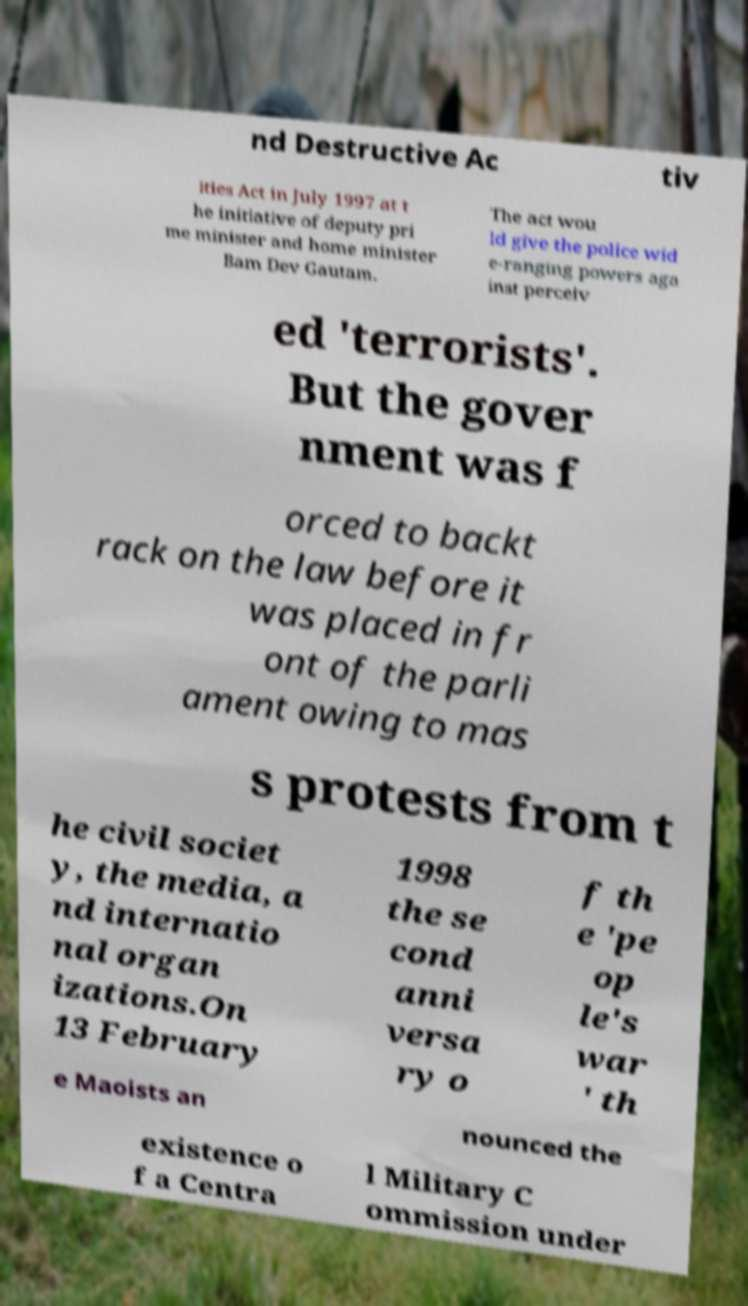Could you extract and type out the text from this image? nd Destructive Ac tiv ities Act in July 1997 at t he initiative of deputy pri me minister and home minister Bam Dev Gautam. The act wou ld give the police wid e-ranging powers aga inst perceiv ed 'terrorists'. But the gover nment was f orced to backt rack on the law before it was placed in fr ont of the parli ament owing to mas s protests from t he civil societ y, the media, a nd internatio nal organ izations.On 13 February 1998 the se cond anni versa ry o f th e 'pe op le's war ' th e Maoists an nounced the existence o f a Centra l Military C ommission under 